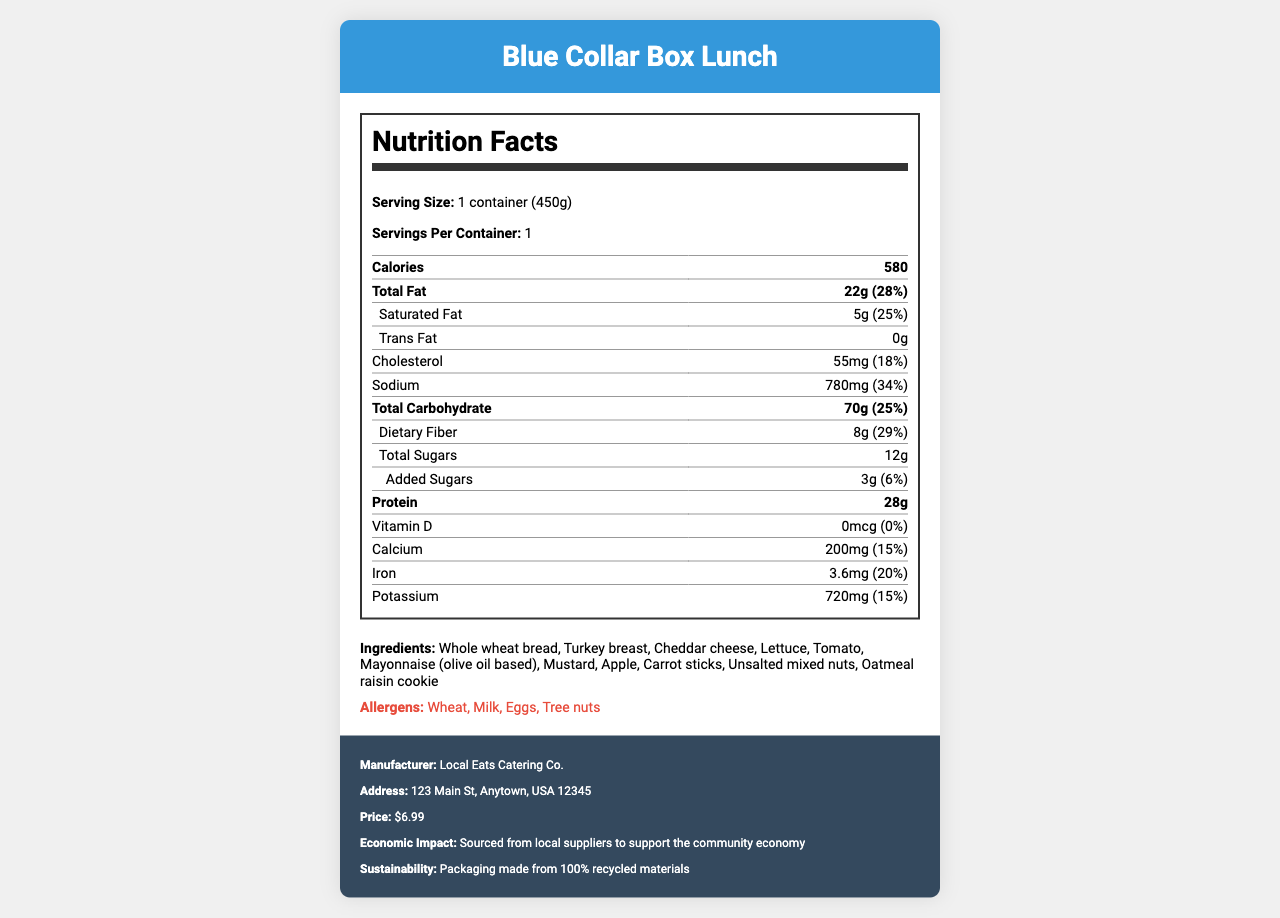what is the serving size for the Blue Collar Box Lunch? The serving size is clearly listed as "1 container (450g)" in the Nutrition Facts section.
Answer: 1 container (450g) How many calories are in one serving of the Blue Collar Box Lunch? The calories per serving are listed directly in the document; it states "Calories 580".
Answer: 580 What is the total fat content in grams and its daily value percentage? The label states "Total Fat 22g (28%)".
Answer: 22g (28%) Which ingredient is a source of dietary fiber in the Blue Collar Box Lunch? Common sources of dietary fiber included in the ingredients list are Whole wheat bread, Apple, and Carrot sticks.
Answer: Whole wheat bread, Apple, Carrot sticks How much protein does one container provide and what percent of the daily value does it represent? The nutrition label specifies "Protein 28g (56%)".
Answer: 28g, 56% Which of the following is not listed as an allergen in the Blue Collar Box Lunch? A. Wheat B. Peanuts C. Eggs D. Milk The allergens listed are Wheat, Milk, Eggs, Tree nuts. Peanuts are not mentioned.
Answer: B. Peanuts In which category does the largest daily value percentage fall? A. Total Fat B. Saturated Fat C. Sodium D. Protein The largest daily value percentage highlighted is Protein with 56%.
Answer: D. Protein Is there any added sugar in the Blue Collar Box Lunch? The nutrition label lists "Added Sugars 3g (6%)".
Answer: Yes Does the document indicate whether the product uses recycled packaging materials? The document mentions "Packaging made from 100% recycled materials" in the sustainability section.
Answer: Yes Summarize the information provided in the document. The document provides comprehensive information including the nutritional content, ingredient list, potential allergens, and additional information about the economic and environmental benefits of the product.
Answer: The document details the nutrition facts, ingredients, allergens, manufacturer information, price, economic impact, and sustainability of the Blue Collar Box Lunch, which is designed to be a budget-friendly, nutritious lunch option for local workers, sourced from local suppliers. Who supplies the Blue Collar Box Lunch? The document mentions "sourced from local suppliers to support the community economy," but it does not specify the names of the suppliers.
Answer: Cannot be determined 